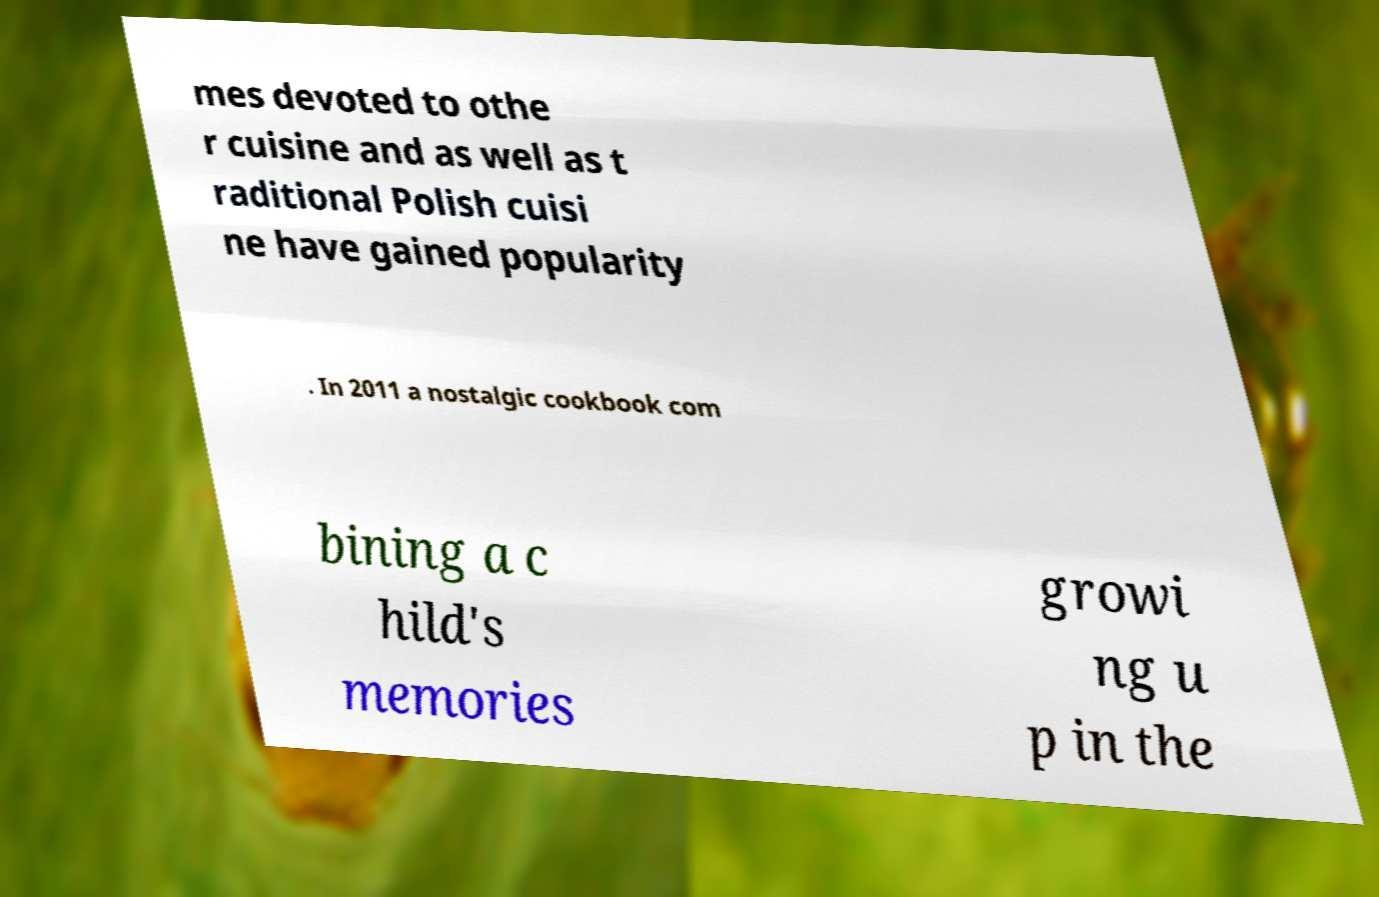For documentation purposes, I need the text within this image transcribed. Could you provide that? mes devoted to othe r cuisine and as well as t raditional Polish cuisi ne have gained popularity . In 2011 a nostalgic cookbook com bining a c hild's memories growi ng u p in the 